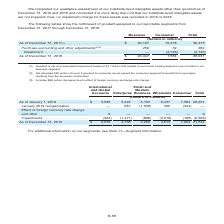According to Centurylink's financial document, What is goodwill assigned to business as of December 31, 2017? According to the financial document, $20,197 (in millions). The relevant text states: "lars in millions) As of December 31, 2017 (1) . $ 20,197 10,278 30,475 Purchase accounting and other adjustments (2)(3) . 250 32 282 Impairment . — (2,726)..." Also, How much of Level 3 goodwill is allocated to consumer? According to the financial document, $32 million. The relevant text states: "(2) We allocated $32 million of Level 3 goodwill to consumer as we expect the consumer segment to benefit from synergies resultin (2) We allocated $32 million of Level 3 goodwill to consumer as we exp..." Also, Which are the reportable segments highlighted in the table? The document shows two values: Business and Consumer. From the document: "Business Consumer Total Business Consumer Total..." Also, can you calculate: What is the amount of goodwill under Business as a ratio of the Total amount as of December 31, 2018? Based on the calculation: 20,447/28,031, the result is 72.94 (percentage). This is based on the information: "As of December 31, 2018 . $ 20,447 7,584 28,031 As of December 31, 2018 . $ 20,447 7,584 28,031..." The key data points involved are: 20,447, 28,031. Also, can you calculate: What is the sum of the total amount of goodwill for 2017 and 2018? Based on the calculation: 30,475+28,031, the result is 58506 (in millions). This is based on the information: "As of December 31, 2018 . $ 20,447 7,584 28,031 ns) As of December 31, 2017 (1) . $ 20,197 10,278 30,475 Purchase accounting and other adjustments (2)(3) . 250 32 282 Impairment . — (2,726) (2,726)..." The key data points involved are: 28,031, 30,475. Also, can you calculate: What is the average total amount of goodwill for 2017 and 2018? To answer this question, I need to perform calculations using the financial data. The calculation is: (30,475+28,031)/2, which equals 29253 (in millions). This is based on the information: "As of December 31, 2018 . $ 20,447 7,584 28,031 ns) As of December 31, 2017 (1) . $ 20,197 10,278 30,475 Purchase accounting and other adjustments (2)(3) . 250 32 282 Impairment . — (2,726) (2,726)..." The key data points involved are: 28,031, 30,475. 